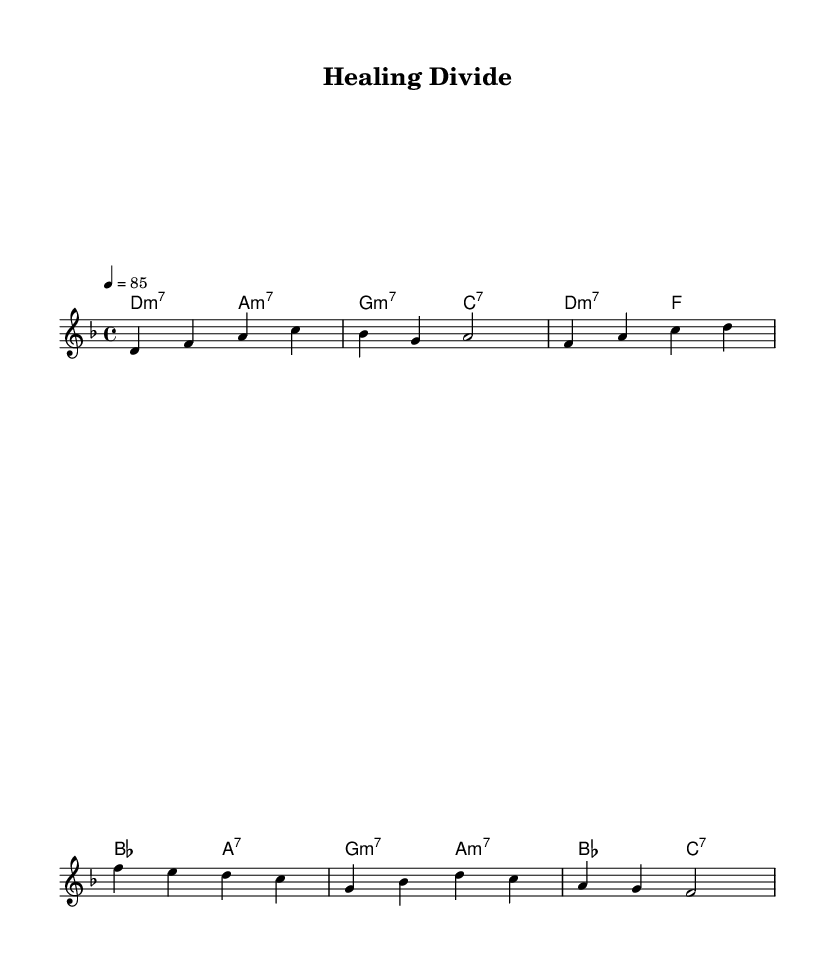What is the key signature of this music? The key signature is indicated at the beginning of the piece, and it shows one flat, which represents D minor (or F major).
Answer: D minor What is the time signature of this music? The time signature is displayed as a fraction at the beginning of the score, specifically 4/4, meaning there are four beats in each measure.
Answer: 4/4 What is the tempo marking for this piece? The tempo marking is found in the score, indicating that the piece should be played at a speed of 85 beats per minute.
Answer: 85 How many measures are in the verse? The verse section is identified in the melody with the notes written out, totaling four measures.
Answer: Four What is the chord progression in the chorus? The chord progression can be seen below the melody and consists of the sequence d minor seven, f major, b flat major, and a seventh chord.
Answer: d minor seven, f major, b flat major, a seventh What theme is addressed in the lyrics? By reading the lyrics, the theme prominently discusses healing and unity in the face of division, suggesting a social message.
Answer: Healing and unity How does the melody reflect the soul music genre? The melody incorporates expressive dynamics and a smooth, flowing style typical of soul, highlighting emotive phrasing that resonates with social themes.
Answer: Expressive dynamics and smooth, emotive phrasing 